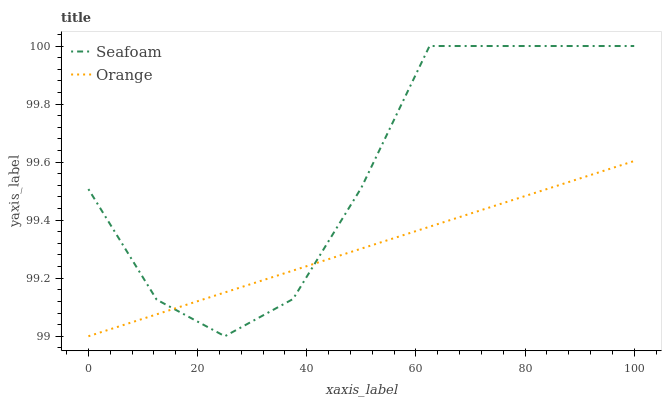Does Orange have the minimum area under the curve?
Answer yes or no. Yes. Does Seafoam have the maximum area under the curve?
Answer yes or no. Yes. Does Seafoam have the minimum area under the curve?
Answer yes or no. No. Is Orange the smoothest?
Answer yes or no. Yes. Is Seafoam the roughest?
Answer yes or no. Yes. Is Seafoam the smoothest?
Answer yes or no. No. Does Orange have the lowest value?
Answer yes or no. Yes. Does Seafoam have the lowest value?
Answer yes or no. No. Does Seafoam have the highest value?
Answer yes or no. Yes. Does Orange intersect Seafoam?
Answer yes or no. Yes. Is Orange less than Seafoam?
Answer yes or no. No. Is Orange greater than Seafoam?
Answer yes or no. No. 